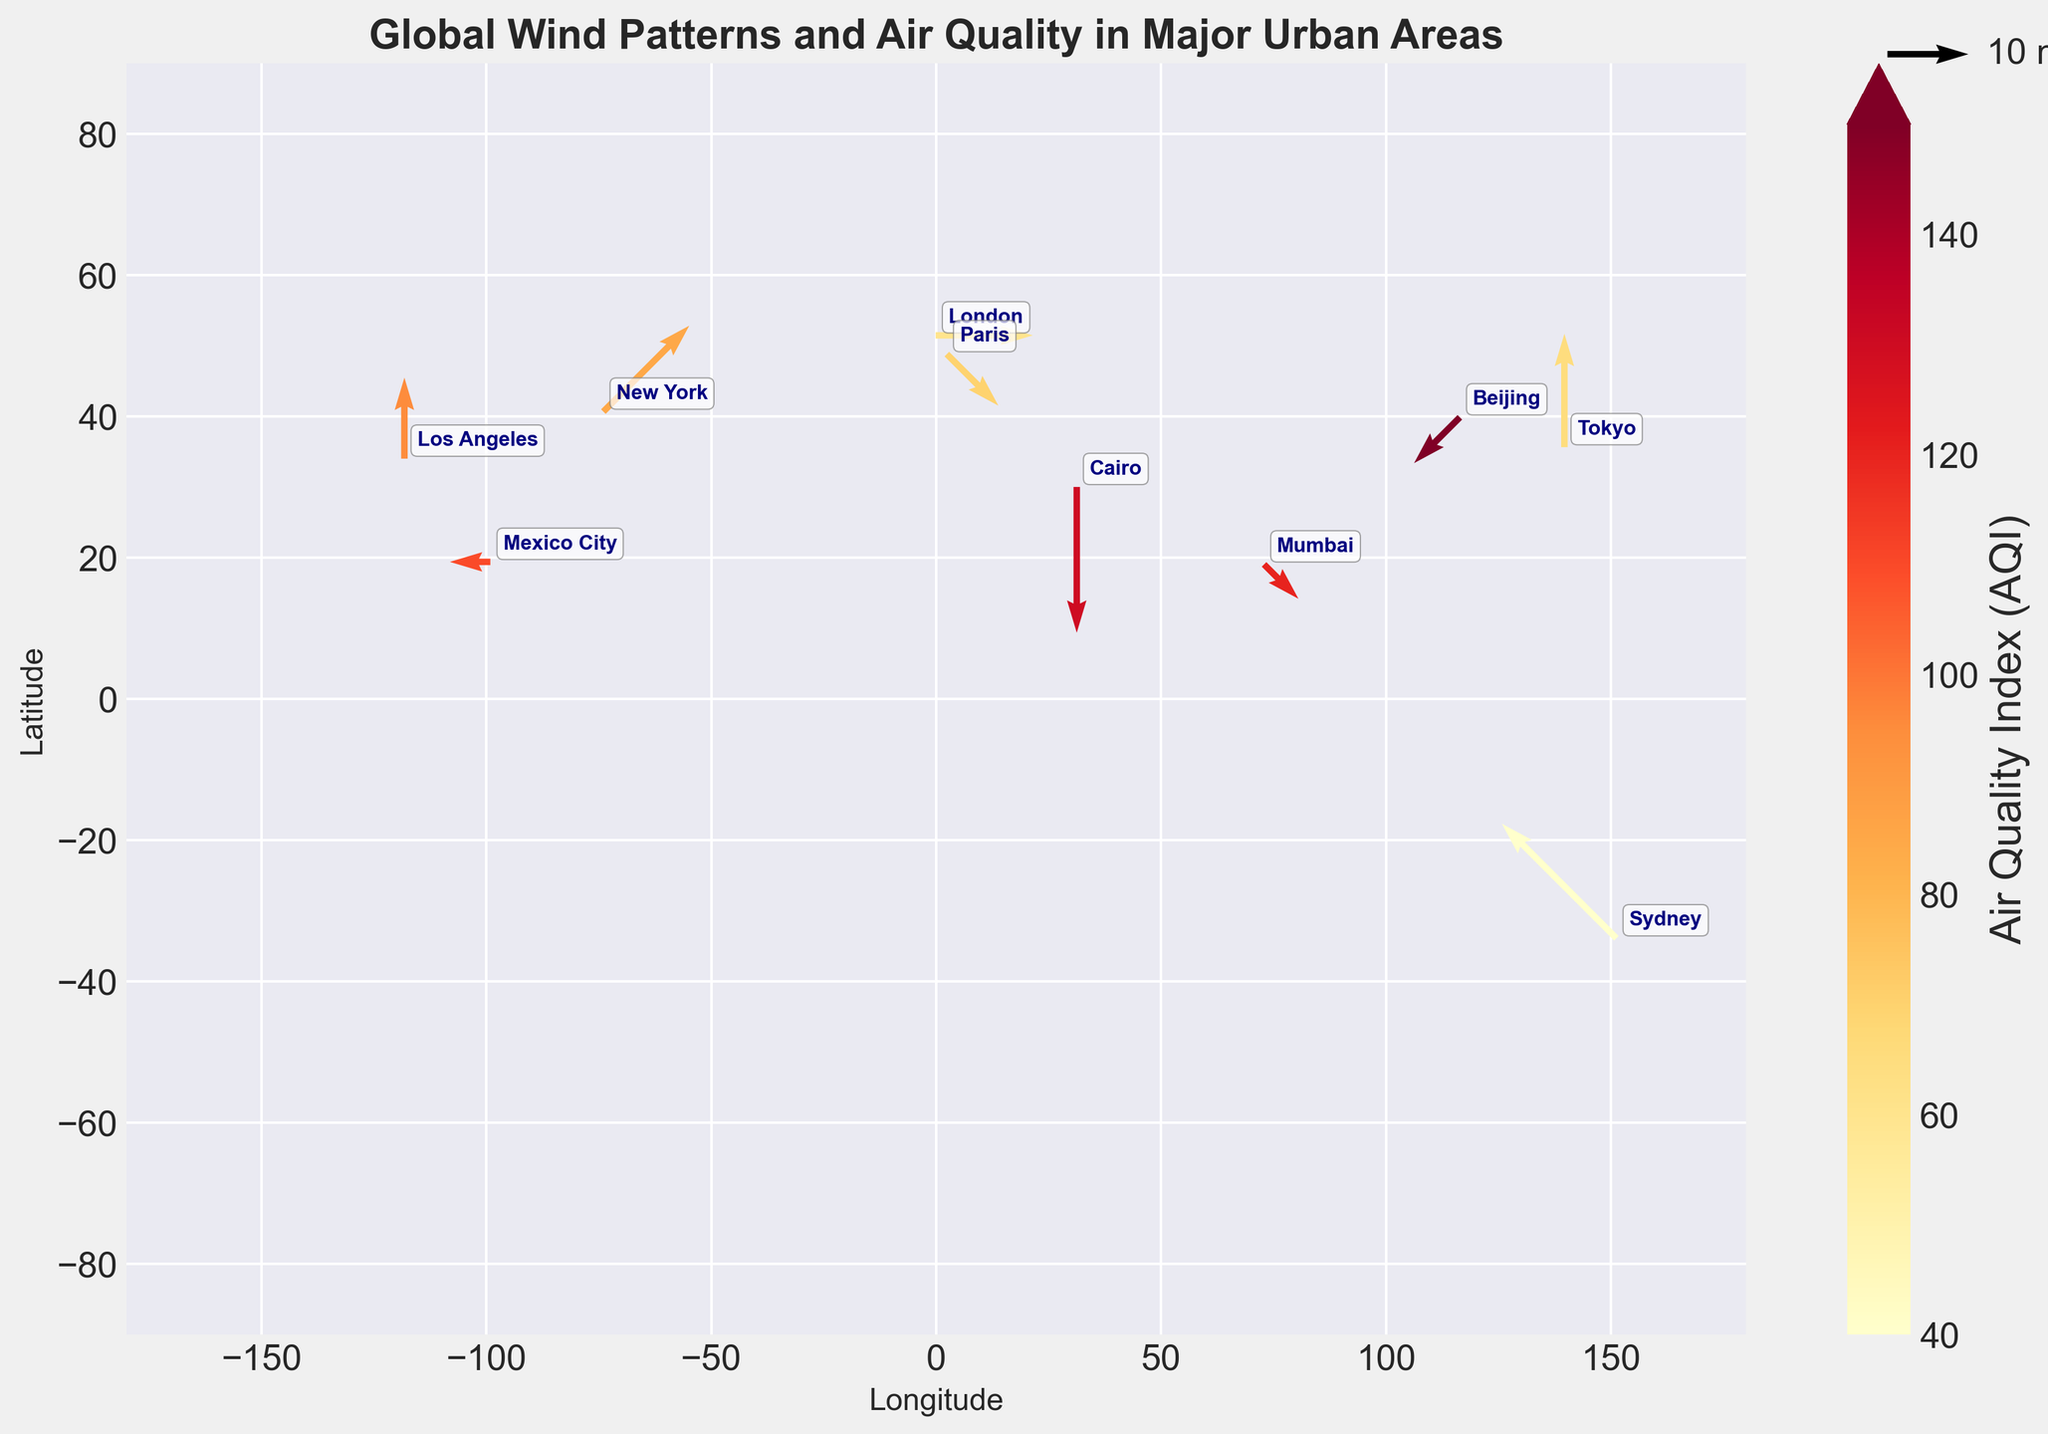Where is the wind speed the highest? By looking at the length and direction of the wind vectors, we can see that Sydney has the longest vectors, indicating the highest wind speed at 20 m/s.
Answer: Sydney Which city has the highest AQI? The color bar indicates the level of AQI, with darker colors representing higher values. Beijing shows the darkest vector color among the cities, indicating the highest AQI of 150.
Answer: Beijing How does the wind direction in Los Angeles compare to that in Tokyo? Los Angeles has wind vectors pointing directly upwards (180 degrees), while Tokyo also has wind vectors pointing upwards (180 degrees). Both cities have the same wind direction.
Answer: Same What is the average wind speed across all cities? The wind speeds are: 15, 8, 12, 6, 10, 18, 20, 5, 9, 14. Summing them up results in 117. Dividing this sum by the number of cities (10) gives an average of 11.7 m/s.
Answer: 11.7 m/s Which city has a lower AQI, Paris or New York? Paris shows a lighter vector color compared to New York. Paris has an AQI of 70 while New York has an AQI of 85, indicating Paris has a lower AQI.
Answer: Paris Which cities have wind directions greater than 180 degrees? By observing the direction of the wind vectors, Mumbai (315 degrees), Paris (315 degrees), and New York (225 degrees) have wind directions greater than 180 degrees.
Answer: Mumbai, Paris, New York How does the wind speed in Cairo compare to Sydney? Cairo has a wind speed of 18 m/s and Sydney has a wind speed of 20 m/s. Hence, Sydney's wind speed is slightly higher than Cairo's.
Answer: Sydney What's the relation between wind speed and AQI for New York and Beijing? New York has a wind speed of 15 m/s and AQI of 85 while Beijing has a wind speed of 8 m/s and AQI of 150. It appears that lower wind speed in Beijing correlates with a higher AQI.
Answer: Lower wind speed, higher AQI for Beijing What is the dominant wind direction in London and Sydney? London has wind vectors pointing to the left (270 degrees) and Sydney has wind vectors pointing diagonally towards the southeast (135 degrees).
Answer: 270 degrees for London, 135 degrees for Sydney 